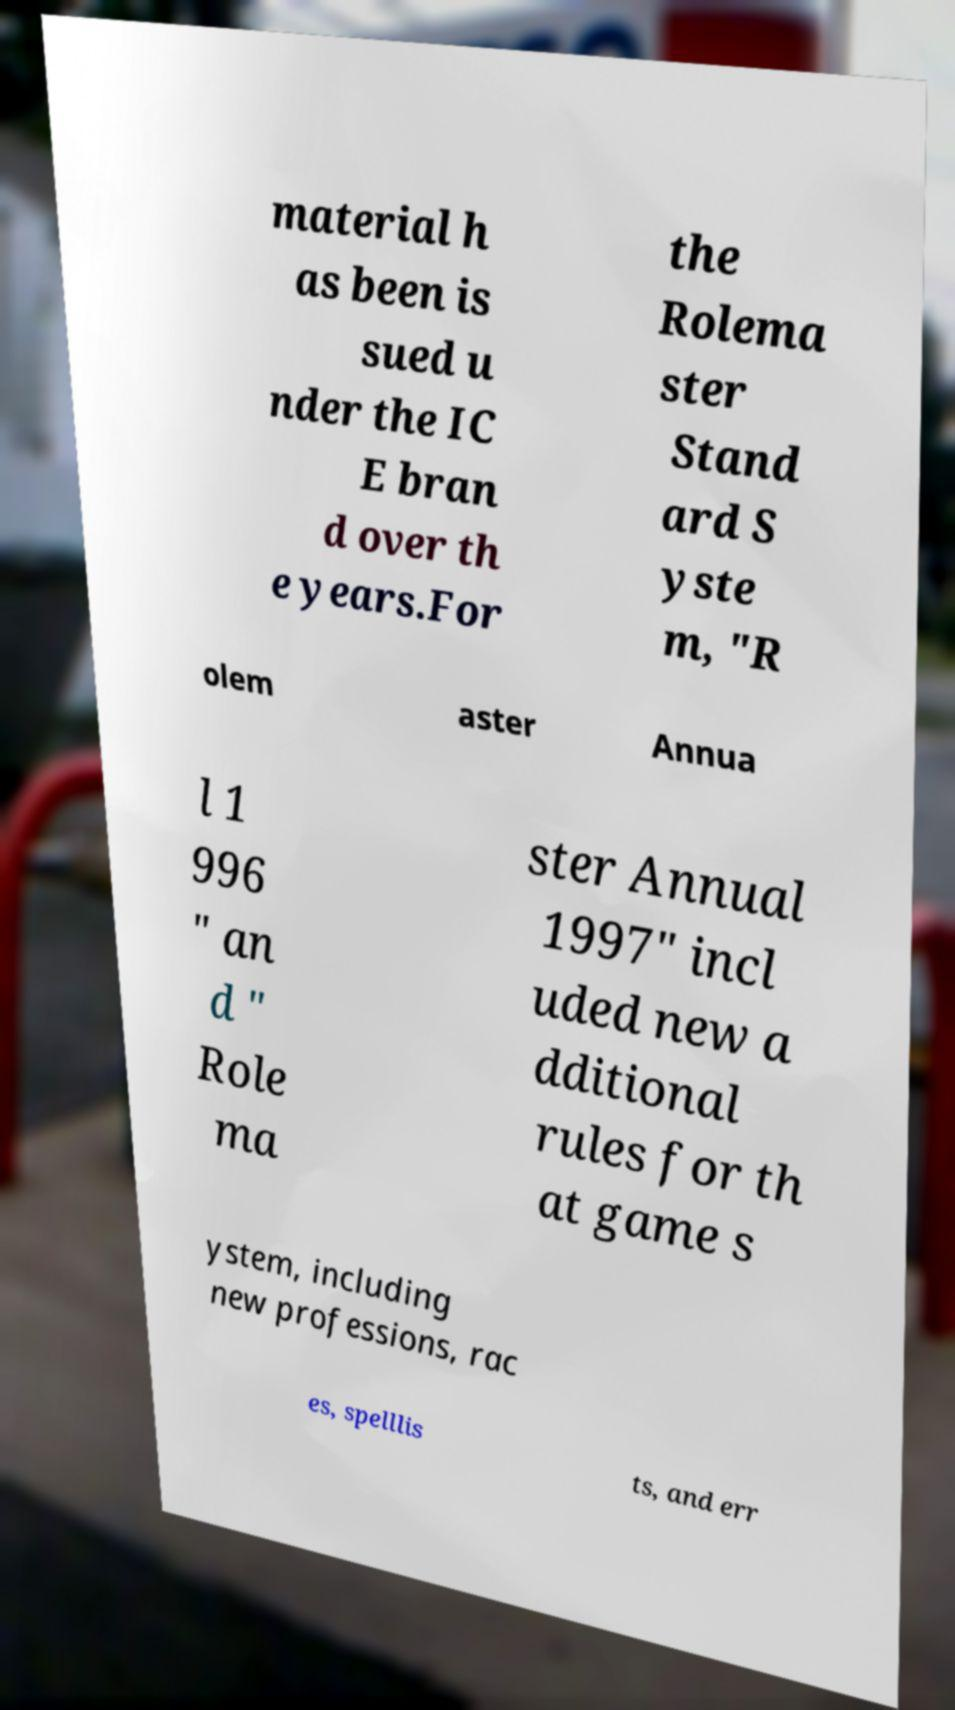For documentation purposes, I need the text within this image transcribed. Could you provide that? material h as been is sued u nder the IC E bran d over th e years.For the Rolema ster Stand ard S yste m, "R olem aster Annua l 1 996 " an d " Role ma ster Annual 1997" incl uded new a dditional rules for th at game s ystem, including new professions, rac es, spelllis ts, and err 